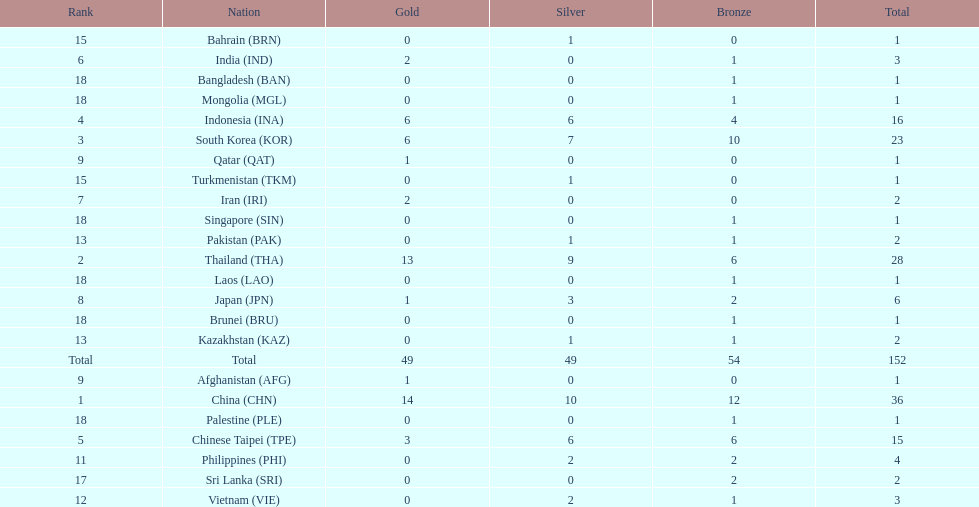Did the philippines or kazakhstan have a higher number of total medals? Philippines. 